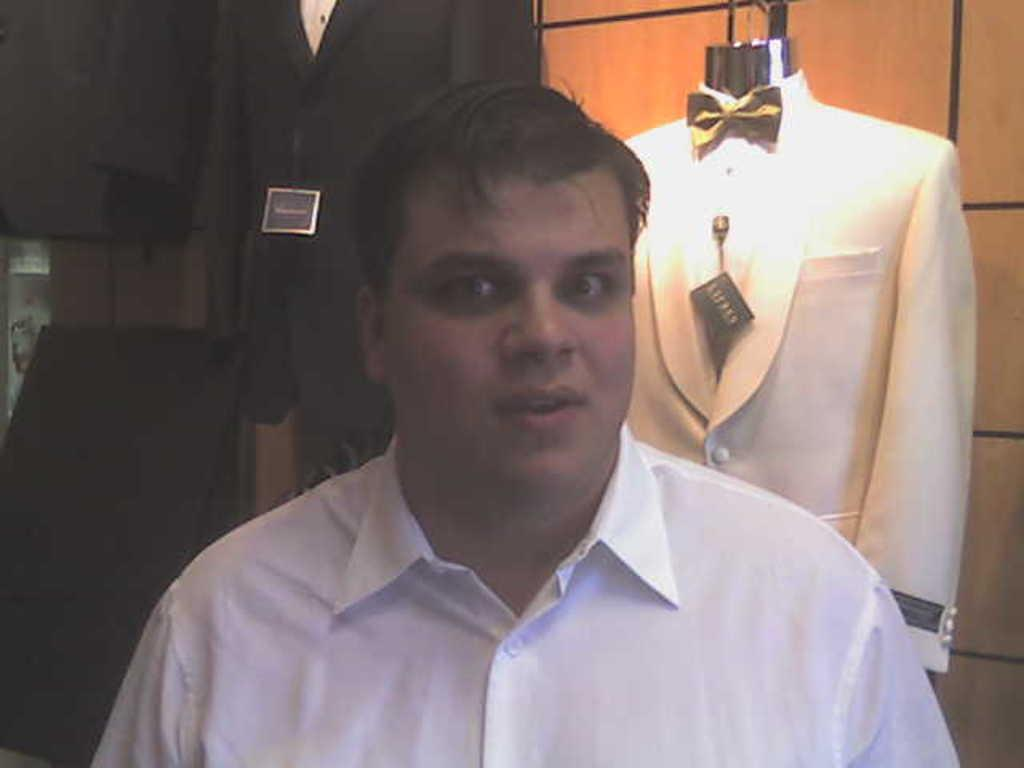What is the main subject of the image? There is a person standing in the image. Where is the person located? The person is in a room. What can be seen in the background of the image? There are clothes with tags in the background of the image. How are the clothes arranged in the image? The clothes are hung on the wall. What type of cheese can be seen melting in the image? There is no cheese present in the image. Is there any smoke or flame visible in the image? No, there is no smoke or flame visible in the image. 